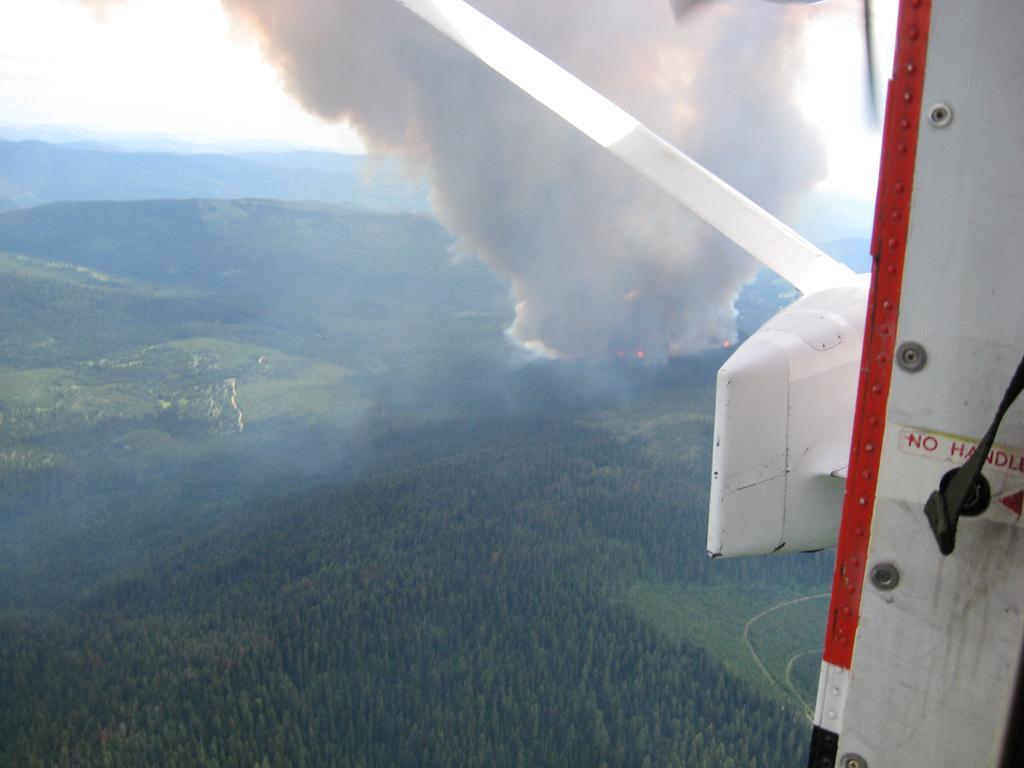In one or two sentences, can you explain what this image depicts? This image is clicked from an aircraft. At the bottom, there are trees and plants along with green grass. And we can see a smoke. 